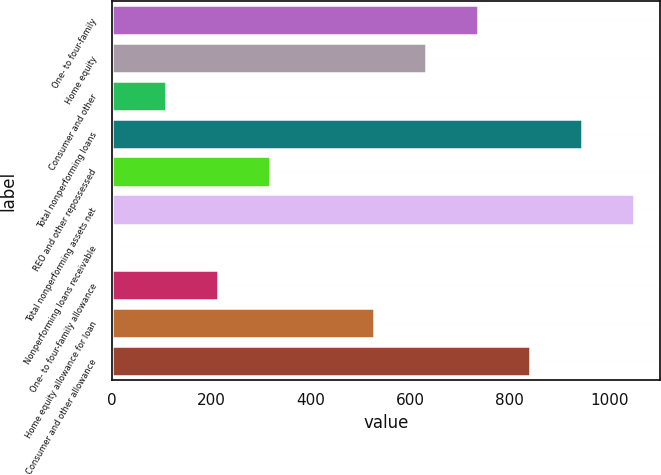Convert chart. <chart><loc_0><loc_0><loc_500><loc_500><bar_chart><fcel>One- to four-family<fcel>Home equity<fcel>Consumer and other<fcel>Total nonperforming loans<fcel>REO and other repossessed<fcel>Total nonperforming assets net<fcel>Nonperforming loans receivable<fcel>One- to four-family allowance<fcel>Home equity allowance for loan<fcel>Consumer and other allowance<nl><fcel>736.24<fcel>631.59<fcel>108.34<fcel>945.54<fcel>317.64<fcel>1050.2<fcel>3.69<fcel>212.99<fcel>526.94<fcel>840.89<nl></chart> 